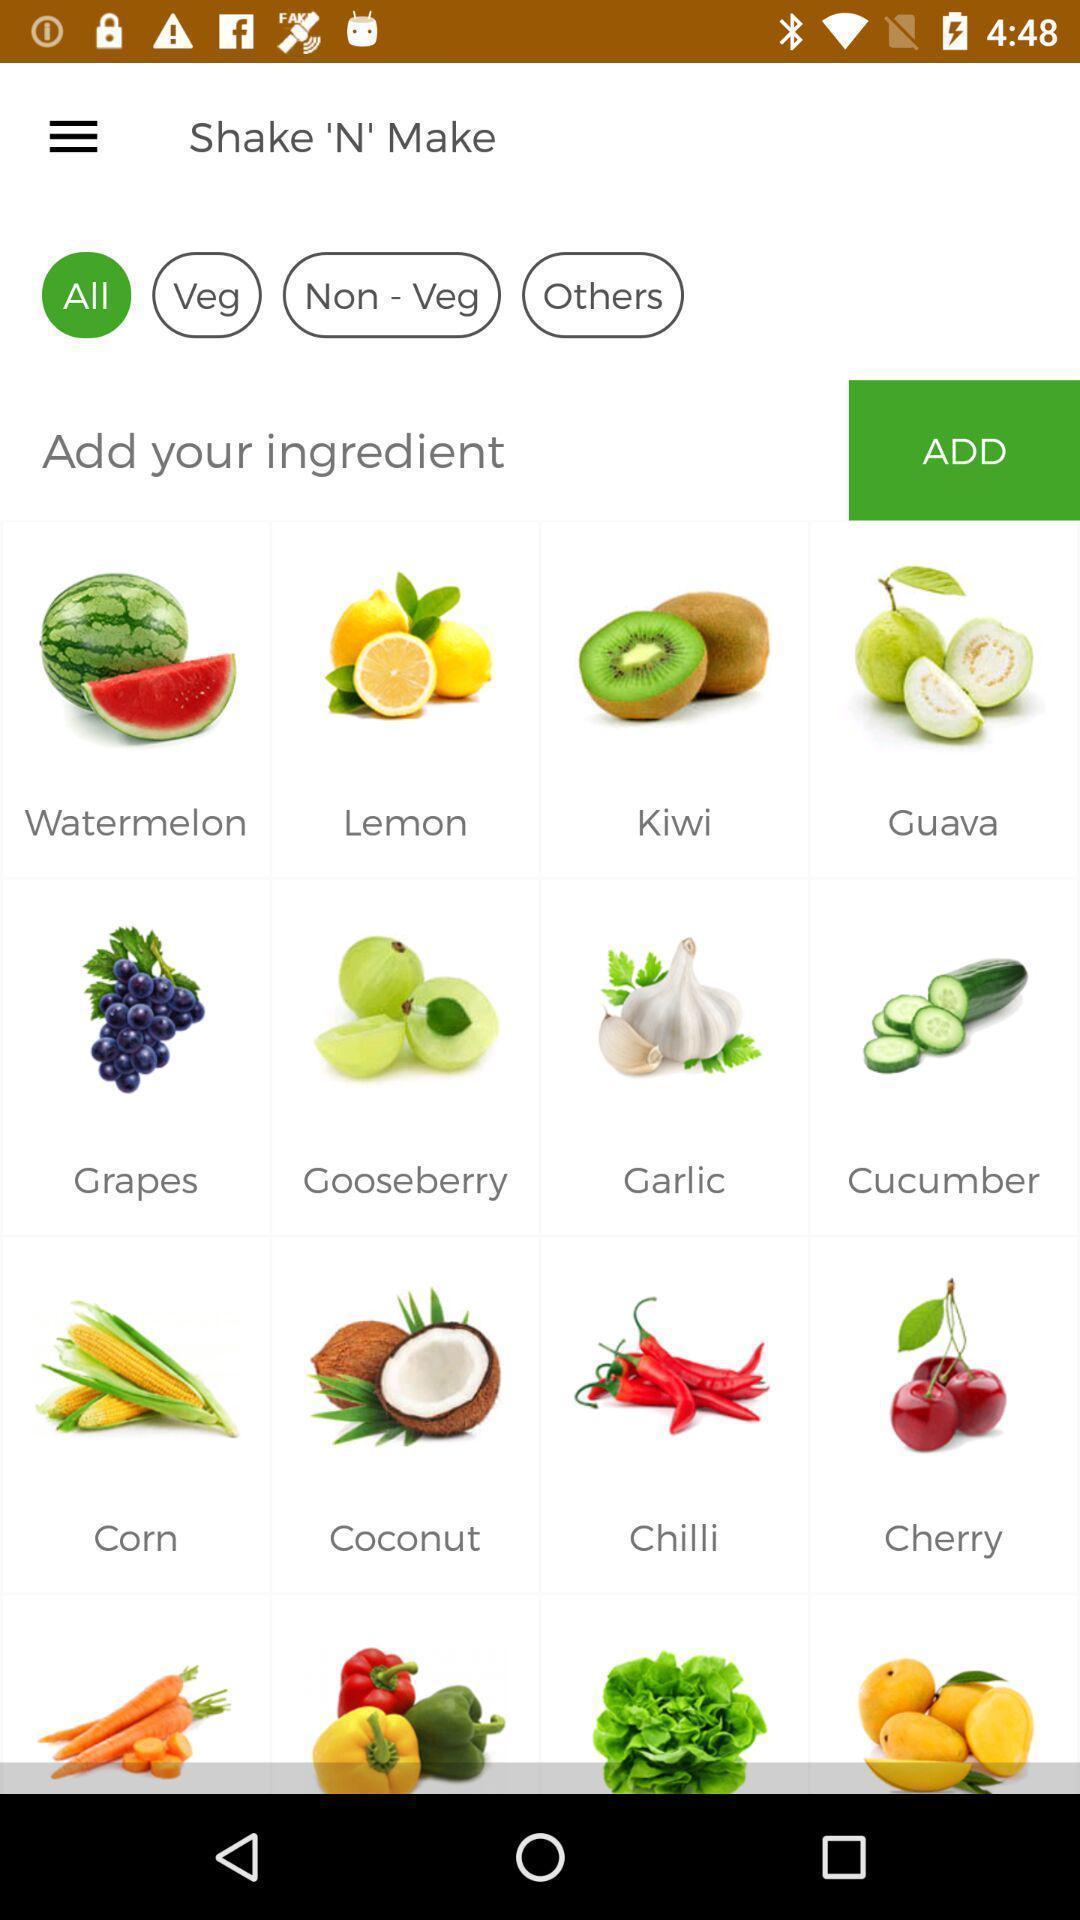Explain the elements present in this screenshot. Page showing various options in a cooking based app. 